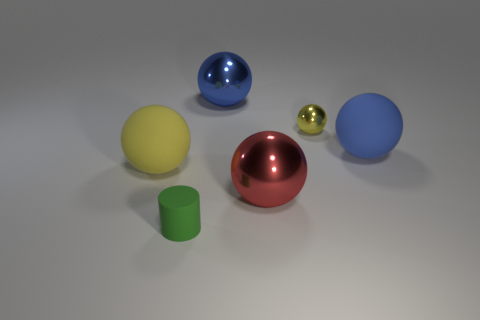Add 4 yellow shiny objects. How many objects exist? 10 Subtract all tiny spheres. How many spheres are left? 4 Subtract all yellow spheres. How many spheres are left? 3 Subtract all cylinders. How many objects are left? 5 Subtract 3 spheres. How many spheres are left? 2 Subtract all big purple balls. Subtract all tiny rubber cylinders. How many objects are left? 5 Add 2 big blue metal things. How many big blue metal things are left? 3 Add 2 large yellow things. How many large yellow things exist? 3 Subtract 1 red balls. How many objects are left? 5 Subtract all brown spheres. Subtract all purple blocks. How many spheres are left? 5 